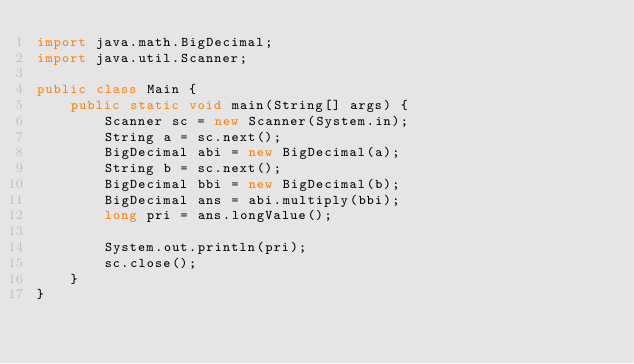<code> <loc_0><loc_0><loc_500><loc_500><_Java_>import java.math.BigDecimal;
import java.util.Scanner;
 
public class Main {    
    public static void main(String[] args) {
        Scanner sc = new Scanner(System.in);
        String a = sc.next();
        BigDecimal abi = new BigDecimal(a);
        String b = sc.next();
        BigDecimal bbi = new BigDecimal(b);
        BigDecimal ans = abi.multiply(bbi);
        long pri = ans.longValue();

        System.out.println(pri);
        sc.close();
    }
}</code> 